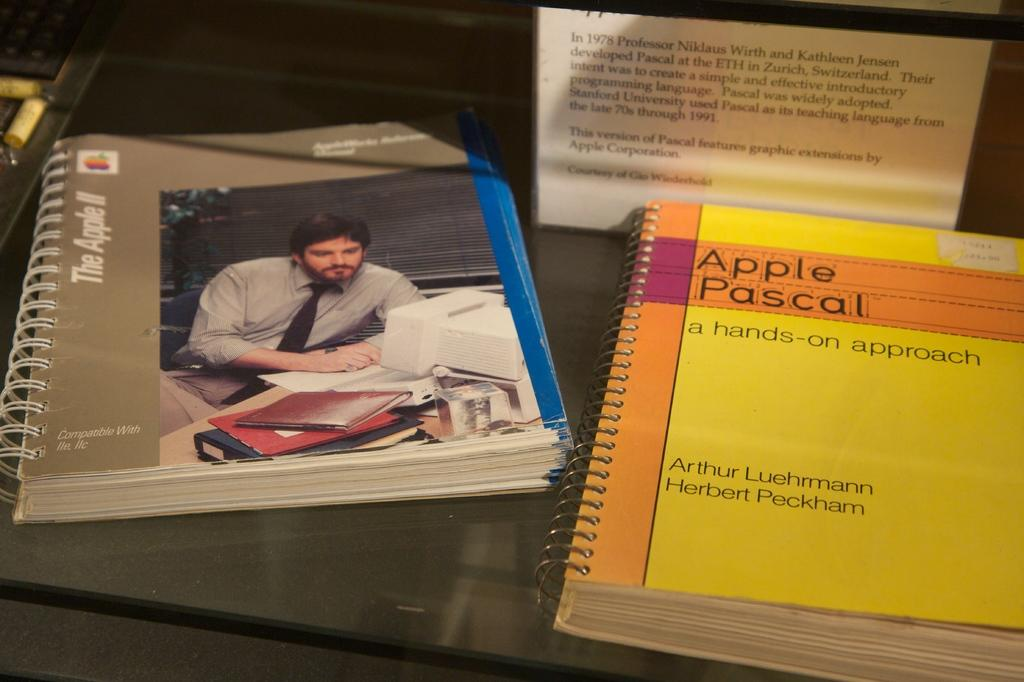<image>
Write a terse but informative summary of the picture. the apple pascal book is on a desk 